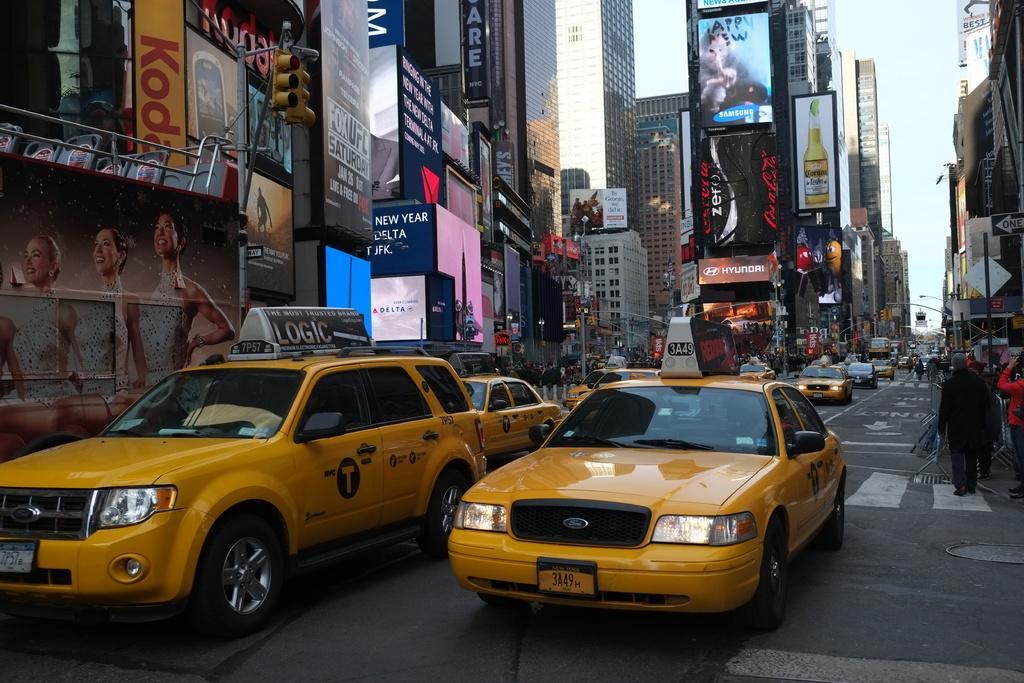Can you describe this image briefly? In the image there are many cars going on the road with people walking on either side of the foot path in front of the buildings with many screens and add banners on it and above its sky. 